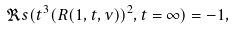<formula> <loc_0><loc_0><loc_500><loc_500>\Re s ( t ^ { 3 } ( R ( 1 , t , \nu ) ) ^ { 2 } , t = \infty ) = - 1 , \,</formula> 